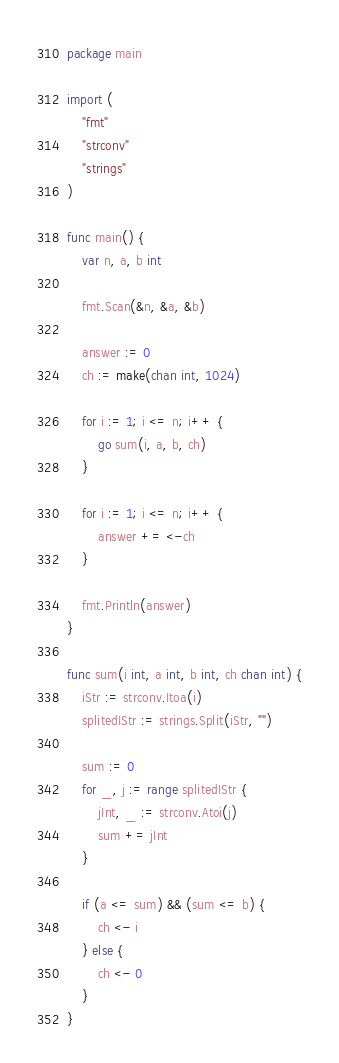Convert code to text. <code><loc_0><loc_0><loc_500><loc_500><_Go_>package main

import (
	"fmt"
	"strconv"
	"strings"
)

func main() {
	var n, a, b int

	fmt.Scan(&n, &a, &b)

	answer := 0
	ch := make(chan int, 1024)

	for i := 1; i <= n; i++ {
		go sum(i, a, b, ch)
	}

	for i := 1; i <= n; i++ {
		answer += <-ch
	}

	fmt.Println(answer)
}

func sum(i int, a int, b int, ch chan int) {
	iStr := strconv.Itoa(i)
	splitedIStr := strings.Split(iStr, "")

	sum := 0
	for _, j := range splitedIStr {
		jInt, _ := strconv.Atoi(j)
		sum += jInt
	}

	if (a <= sum) && (sum <= b) {
		ch <- i
	} else {
		ch <- 0
	}
}
</code> 